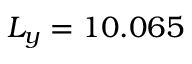<formula> <loc_0><loc_0><loc_500><loc_500>L _ { y } = 1 0 . 0 6 5</formula> 